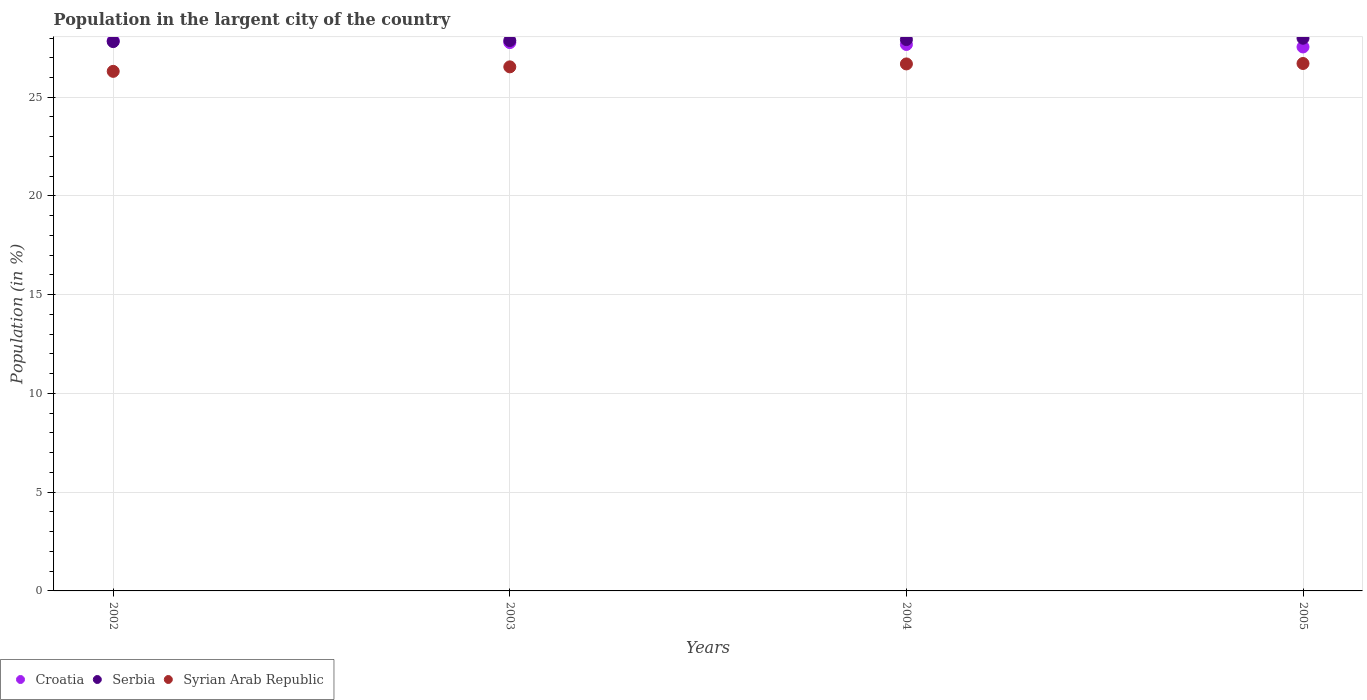What is the percentage of population in the largent city in Croatia in 2005?
Make the answer very short. 27.55. Across all years, what is the maximum percentage of population in the largent city in Serbia?
Ensure brevity in your answer.  27.99. Across all years, what is the minimum percentage of population in the largent city in Serbia?
Give a very brief answer. 27.82. In which year was the percentage of population in the largent city in Croatia maximum?
Your answer should be very brief. 2002. What is the total percentage of population in the largent city in Croatia in the graph?
Give a very brief answer. 110.85. What is the difference between the percentage of population in the largent city in Croatia in 2002 and that in 2005?
Offer a very short reply. 0.32. What is the difference between the percentage of population in the largent city in Serbia in 2002 and the percentage of population in the largent city in Croatia in 2005?
Provide a short and direct response. 0.27. What is the average percentage of population in the largent city in Serbia per year?
Your response must be concise. 27.9. In the year 2005, what is the difference between the percentage of population in the largent city in Serbia and percentage of population in the largent city in Croatia?
Offer a very short reply. 0.44. What is the ratio of the percentage of population in the largent city in Croatia in 2003 to that in 2005?
Your answer should be compact. 1.01. Is the percentage of population in the largent city in Croatia in 2004 less than that in 2005?
Offer a terse response. No. Is the difference between the percentage of population in the largent city in Serbia in 2003 and 2005 greater than the difference between the percentage of population in the largent city in Croatia in 2003 and 2005?
Ensure brevity in your answer.  No. What is the difference between the highest and the second highest percentage of population in the largent city in Croatia?
Give a very brief answer. 0.1. What is the difference between the highest and the lowest percentage of population in the largent city in Serbia?
Give a very brief answer. 0.17. Is the sum of the percentage of population in the largent city in Serbia in 2002 and 2004 greater than the maximum percentage of population in the largent city in Syrian Arab Republic across all years?
Make the answer very short. Yes. Does the percentage of population in the largent city in Serbia monotonically increase over the years?
Offer a very short reply. Yes. Is the percentage of population in the largent city in Croatia strictly greater than the percentage of population in the largent city in Syrian Arab Republic over the years?
Offer a very short reply. Yes. Is the percentage of population in the largent city in Serbia strictly less than the percentage of population in the largent city in Syrian Arab Republic over the years?
Keep it short and to the point. No. How many years are there in the graph?
Your response must be concise. 4. What is the difference between two consecutive major ticks on the Y-axis?
Provide a succinct answer. 5. Does the graph contain grids?
Your response must be concise. Yes. What is the title of the graph?
Ensure brevity in your answer.  Population in the largent city of the country. What is the Population (in %) of Croatia in 2002?
Your answer should be very brief. 27.86. What is the Population (in %) of Serbia in 2002?
Make the answer very short. 27.82. What is the Population (in %) of Syrian Arab Republic in 2002?
Make the answer very short. 26.31. What is the Population (in %) of Croatia in 2003?
Offer a terse response. 27.77. What is the Population (in %) of Serbia in 2003?
Offer a terse response. 27.87. What is the Population (in %) in Syrian Arab Republic in 2003?
Your response must be concise. 26.54. What is the Population (in %) of Croatia in 2004?
Offer a terse response. 27.67. What is the Population (in %) of Serbia in 2004?
Offer a terse response. 27.92. What is the Population (in %) in Syrian Arab Republic in 2004?
Your answer should be very brief. 26.69. What is the Population (in %) in Croatia in 2005?
Provide a short and direct response. 27.55. What is the Population (in %) of Serbia in 2005?
Your answer should be compact. 27.99. What is the Population (in %) in Syrian Arab Republic in 2005?
Ensure brevity in your answer.  26.71. Across all years, what is the maximum Population (in %) of Croatia?
Offer a terse response. 27.86. Across all years, what is the maximum Population (in %) in Serbia?
Provide a short and direct response. 27.99. Across all years, what is the maximum Population (in %) of Syrian Arab Republic?
Give a very brief answer. 26.71. Across all years, what is the minimum Population (in %) of Croatia?
Your answer should be compact. 27.55. Across all years, what is the minimum Population (in %) of Serbia?
Offer a very short reply. 27.82. Across all years, what is the minimum Population (in %) of Syrian Arab Republic?
Offer a very short reply. 26.31. What is the total Population (in %) in Croatia in the graph?
Provide a short and direct response. 110.85. What is the total Population (in %) of Serbia in the graph?
Provide a short and direct response. 111.6. What is the total Population (in %) of Syrian Arab Republic in the graph?
Provide a short and direct response. 106.25. What is the difference between the Population (in %) of Croatia in 2002 and that in 2003?
Make the answer very short. 0.1. What is the difference between the Population (in %) in Serbia in 2002 and that in 2003?
Your response must be concise. -0.05. What is the difference between the Population (in %) of Syrian Arab Republic in 2002 and that in 2003?
Your answer should be compact. -0.23. What is the difference between the Population (in %) in Croatia in 2002 and that in 2004?
Your response must be concise. 0.19. What is the difference between the Population (in %) of Serbia in 2002 and that in 2004?
Your response must be concise. -0.1. What is the difference between the Population (in %) in Syrian Arab Republic in 2002 and that in 2004?
Make the answer very short. -0.38. What is the difference between the Population (in %) in Croatia in 2002 and that in 2005?
Your answer should be very brief. 0.32. What is the difference between the Population (in %) in Serbia in 2002 and that in 2005?
Your answer should be compact. -0.17. What is the difference between the Population (in %) in Syrian Arab Republic in 2002 and that in 2005?
Provide a short and direct response. -0.4. What is the difference between the Population (in %) in Croatia in 2003 and that in 2004?
Offer a terse response. 0.1. What is the difference between the Population (in %) in Serbia in 2003 and that in 2004?
Offer a very short reply. -0.05. What is the difference between the Population (in %) in Syrian Arab Republic in 2003 and that in 2004?
Your answer should be very brief. -0.15. What is the difference between the Population (in %) in Croatia in 2003 and that in 2005?
Your answer should be very brief. 0.22. What is the difference between the Population (in %) in Serbia in 2003 and that in 2005?
Your answer should be compact. -0.12. What is the difference between the Population (in %) in Syrian Arab Republic in 2003 and that in 2005?
Offer a terse response. -0.17. What is the difference between the Population (in %) of Croatia in 2004 and that in 2005?
Your answer should be compact. 0.13. What is the difference between the Population (in %) in Serbia in 2004 and that in 2005?
Provide a succinct answer. -0.07. What is the difference between the Population (in %) in Syrian Arab Republic in 2004 and that in 2005?
Your answer should be compact. -0.02. What is the difference between the Population (in %) of Croatia in 2002 and the Population (in %) of Serbia in 2003?
Provide a succinct answer. -0.01. What is the difference between the Population (in %) of Croatia in 2002 and the Population (in %) of Syrian Arab Republic in 2003?
Your answer should be compact. 1.32. What is the difference between the Population (in %) of Serbia in 2002 and the Population (in %) of Syrian Arab Republic in 2003?
Give a very brief answer. 1.28. What is the difference between the Population (in %) in Croatia in 2002 and the Population (in %) in Serbia in 2004?
Make the answer very short. -0.06. What is the difference between the Population (in %) of Croatia in 2002 and the Population (in %) of Syrian Arab Republic in 2004?
Keep it short and to the point. 1.18. What is the difference between the Population (in %) in Serbia in 2002 and the Population (in %) in Syrian Arab Republic in 2004?
Your answer should be compact. 1.13. What is the difference between the Population (in %) of Croatia in 2002 and the Population (in %) of Serbia in 2005?
Offer a very short reply. -0.12. What is the difference between the Population (in %) of Croatia in 2002 and the Population (in %) of Syrian Arab Republic in 2005?
Your answer should be compact. 1.15. What is the difference between the Population (in %) in Serbia in 2002 and the Population (in %) in Syrian Arab Republic in 2005?
Offer a very short reply. 1.11. What is the difference between the Population (in %) of Croatia in 2003 and the Population (in %) of Serbia in 2004?
Provide a short and direct response. -0.15. What is the difference between the Population (in %) of Croatia in 2003 and the Population (in %) of Syrian Arab Republic in 2004?
Your answer should be compact. 1.08. What is the difference between the Population (in %) of Serbia in 2003 and the Population (in %) of Syrian Arab Republic in 2004?
Make the answer very short. 1.18. What is the difference between the Population (in %) in Croatia in 2003 and the Population (in %) in Serbia in 2005?
Keep it short and to the point. -0.22. What is the difference between the Population (in %) in Croatia in 2003 and the Population (in %) in Syrian Arab Republic in 2005?
Offer a terse response. 1.06. What is the difference between the Population (in %) of Serbia in 2003 and the Population (in %) of Syrian Arab Republic in 2005?
Give a very brief answer. 1.16. What is the difference between the Population (in %) of Croatia in 2004 and the Population (in %) of Serbia in 2005?
Keep it short and to the point. -0.32. What is the difference between the Population (in %) in Croatia in 2004 and the Population (in %) in Syrian Arab Republic in 2005?
Provide a succinct answer. 0.96. What is the difference between the Population (in %) in Serbia in 2004 and the Population (in %) in Syrian Arab Republic in 2005?
Your answer should be compact. 1.21. What is the average Population (in %) of Croatia per year?
Make the answer very short. 27.71. What is the average Population (in %) of Serbia per year?
Provide a succinct answer. 27.9. What is the average Population (in %) of Syrian Arab Republic per year?
Give a very brief answer. 26.56. In the year 2002, what is the difference between the Population (in %) of Croatia and Population (in %) of Serbia?
Give a very brief answer. 0.05. In the year 2002, what is the difference between the Population (in %) in Croatia and Population (in %) in Syrian Arab Republic?
Provide a succinct answer. 1.55. In the year 2002, what is the difference between the Population (in %) in Serbia and Population (in %) in Syrian Arab Republic?
Your response must be concise. 1.51. In the year 2003, what is the difference between the Population (in %) in Croatia and Population (in %) in Serbia?
Your answer should be very brief. -0.1. In the year 2003, what is the difference between the Population (in %) in Croatia and Population (in %) in Syrian Arab Republic?
Offer a very short reply. 1.23. In the year 2003, what is the difference between the Population (in %) in Serbia and Population (in %) in Syrian Arab Republic?
Give a very brief answer. 1.33. In the year 2004, what is the difference between the Population (in %) in Croatia and Population (in %) in Serbia?
Offer a very short reply. -0.25. In the year 2004, what is the difference between the Population (in %) of Croatia and Population (in %) of Syrian Arab Republic?
Offer a very short reply. 0.99. In the year 2004, what is the difference between the Population (in %) of Serbia and Population (in %) of Syrian Arab Republic?
Give a very brief answer. 1.23. In the year 2005, what is the difference between the Population (in %) of Croatia and Population (in %) of Serbia?
Offer a very short reply. -0.44. In the year 2005, what is the difference between the Population (in %) of Croatia and Population (in %) of Syrian Arab Republic?
Ensure brevity in your answer.  0.84. In the year 2005, what is the difference between the Population (in %) of Serbia and Population (in %) of Syrian Arab Republic?
Give a very brief answer. 1.28. What is the ratio of the Population (in %) in Syrian Arab Republic in 2002 to that in 2003?
Offer a very short reply. 0.99. What is the ratio of the Population (in %) of Croatia in 2002 to that in 2004?
Your answer should be compact. 1.01. What is the ratio of the Population (in %) of Syrian Arab Republic in 2002 to that in 2004?
Your answer should be compact. 0.99. What is the ratio of the Population (in %) of Croatia in 2002 to that in 2005?
Your answer should be very brief. 1.01. What is the ratio of the Population (in %) in Serbia in 2002 to that in 2005?
Offer a very short reply. 0.99. What is the ratio of the Population (in %) of Syrian Arab Republic in 2002 to that in 2005?
Make the answer very short. 0.99. What is the ratio of the Population (in %) in Croatia in 2003 to that in 2005?
Keep it short and to the point. 1.01. What is the ratio of the Population (in %) in Serbia in 2003 to that in 2005?
Your answer should be compact. 1. What is the ratio of the Population (in %) of Croatia in 2004 to that in 2005?
Make the answer very short. 1. What is the ratio of the Population (in %) in Serbia in 2004 to that in 2005?
Keep it short and to the point. 1. What is the ratio of the Population (in %) in Syrian Arab Republic in 2004 to that in 2005?
Provide a succinct answer. 1. What is the difference between the highest and the second highest Population (in %) in Croatia?
Offer a very short reply. 0.1. What is the difference between the highest and the second highest Population (in %) of Serbia?
Provide a short and direct response. 0.07. What is the difference between the highest and the second highest Population (in %) in Syrian Arab Republic?
Offer a very short reply. 0.02. What is the difference between the highest and the lowest Population (in %) of Croatia?
Your response must be concise. 0.32. What is the difference between the highest and the lowest Population (in %) in Serbia?
Make the answer very short. 0.17. What is the difference between the highest and the lowest Population (in %) in Syrian Arab Republic?
Offer a terse response. 0.4. 